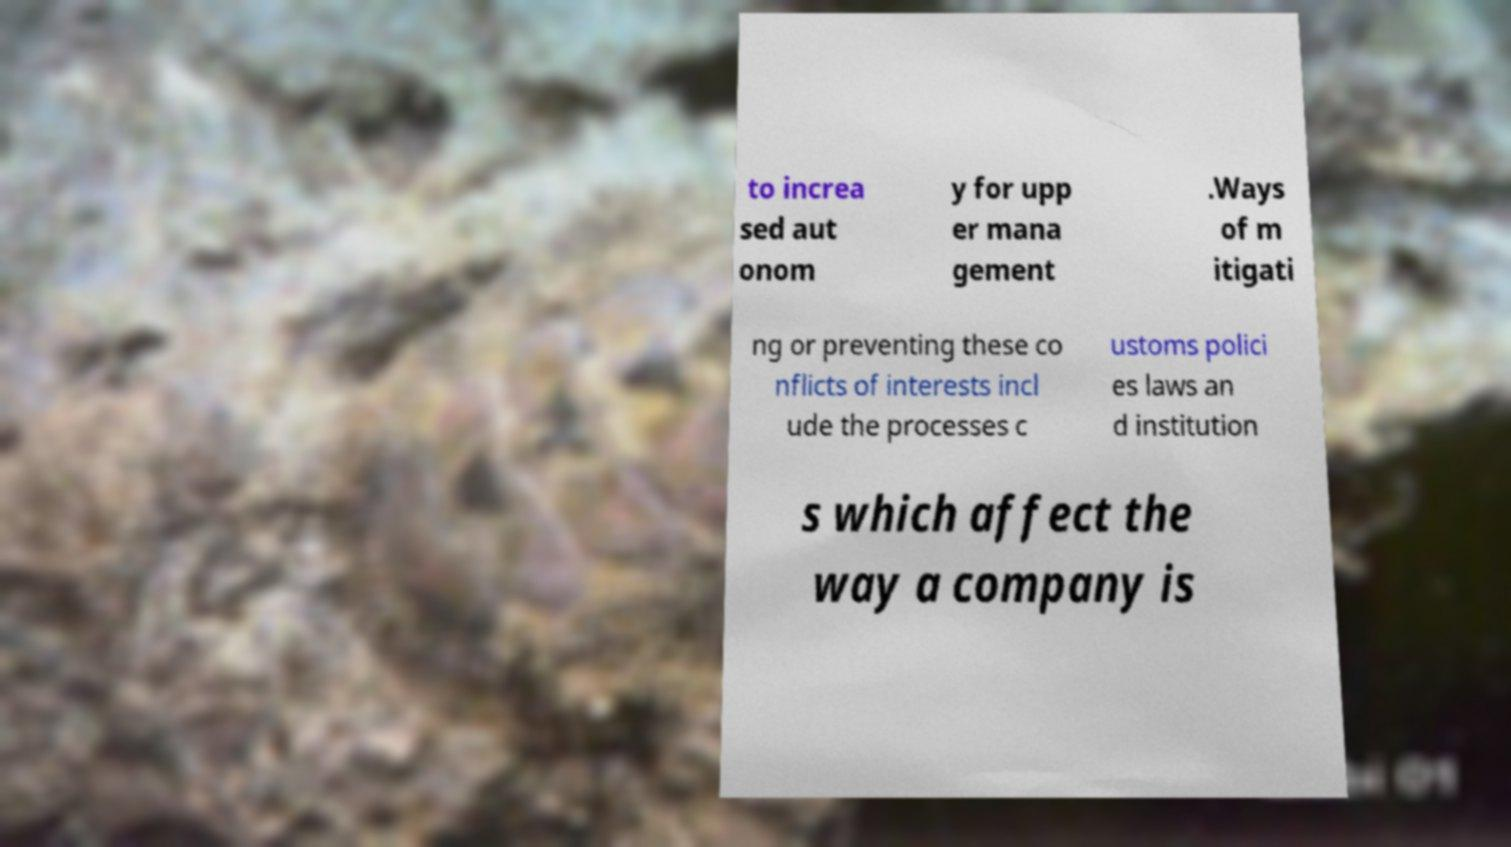Can you accurately transcribe the text from the provided image for me? to increa sed aut onom y for upp er mana gement .Ways of m itigati ng or preventing these co nflicts of interests incl ude the processes c ustoms polici es laws an d institution s which affect the way a company is 